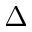<formula> <loc_0><loc_0><loc_500><loc_500>\Delta</formula> 